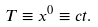<formula> <loc_0><loc_0><loc_500><loc_500>T \equiv x ^ { 0 } \equiv c t .</formula> 